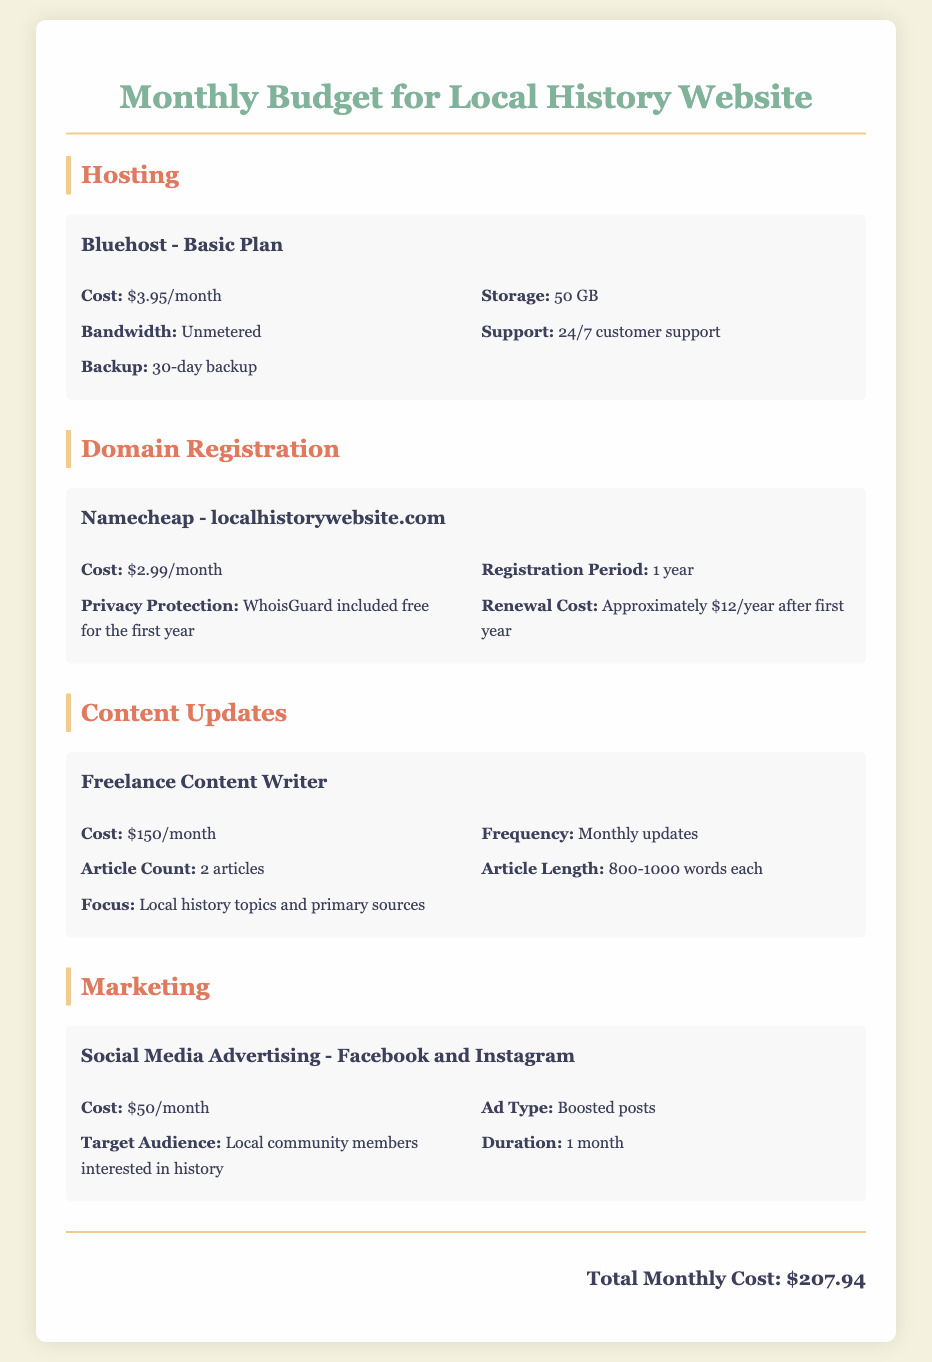What is the cost of hosting? The document specifies the cost of the Bluehost Basic Plan for hosting as $3.95/month.
Answer: $3.95/month How much is spent on domain registration? The document lists the cost for Namecheap domain registration as $2.99/month.
Answer: $2.99/month What is the total monthly cost for maintaining the website? The total monthly cost is clearly stated as $207.94 at the bottom of the document.
Answer: $207.94 How many articles does the freelance content writer produce monthly? The document mentions that the content writer produces 2 articles each month.
Answer: 2 articles What is the duration of the social media advertising? The document indicates that the duration for the advertising on Facebook and Instagram is 1 month.
Answer: 1 month What is included for the first year of the domain registration? The document states that WhoisGuard is included free for the first year of domain registration.
Answer: WhoisGuard What is the article length for content updates? The document specifies that each article is between 800-1000 words in length.
Answer: 800-1000 words What type of support is offered with the hosting plan? The document indicates that the hosting plan includes 24/7 customer support.
Answer: 24/7 customer support What is the focus of the articles produced by the content writer? The document states the focus is on local history topics and primary sources.
Answer: Local history topics and primary sources 